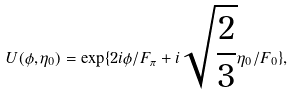Convert formula to latex. <formula><loc_0><loc_0><loc_500><loc_500>U ( \phi , \eta _ { 0 } ) = \exp \{ 2 i \phi / F _ { \pi } + i \sqrt { \frac { 2 } { 3 } } \eta _ { 0 } / F _ { 0 } \} ,</formula> 